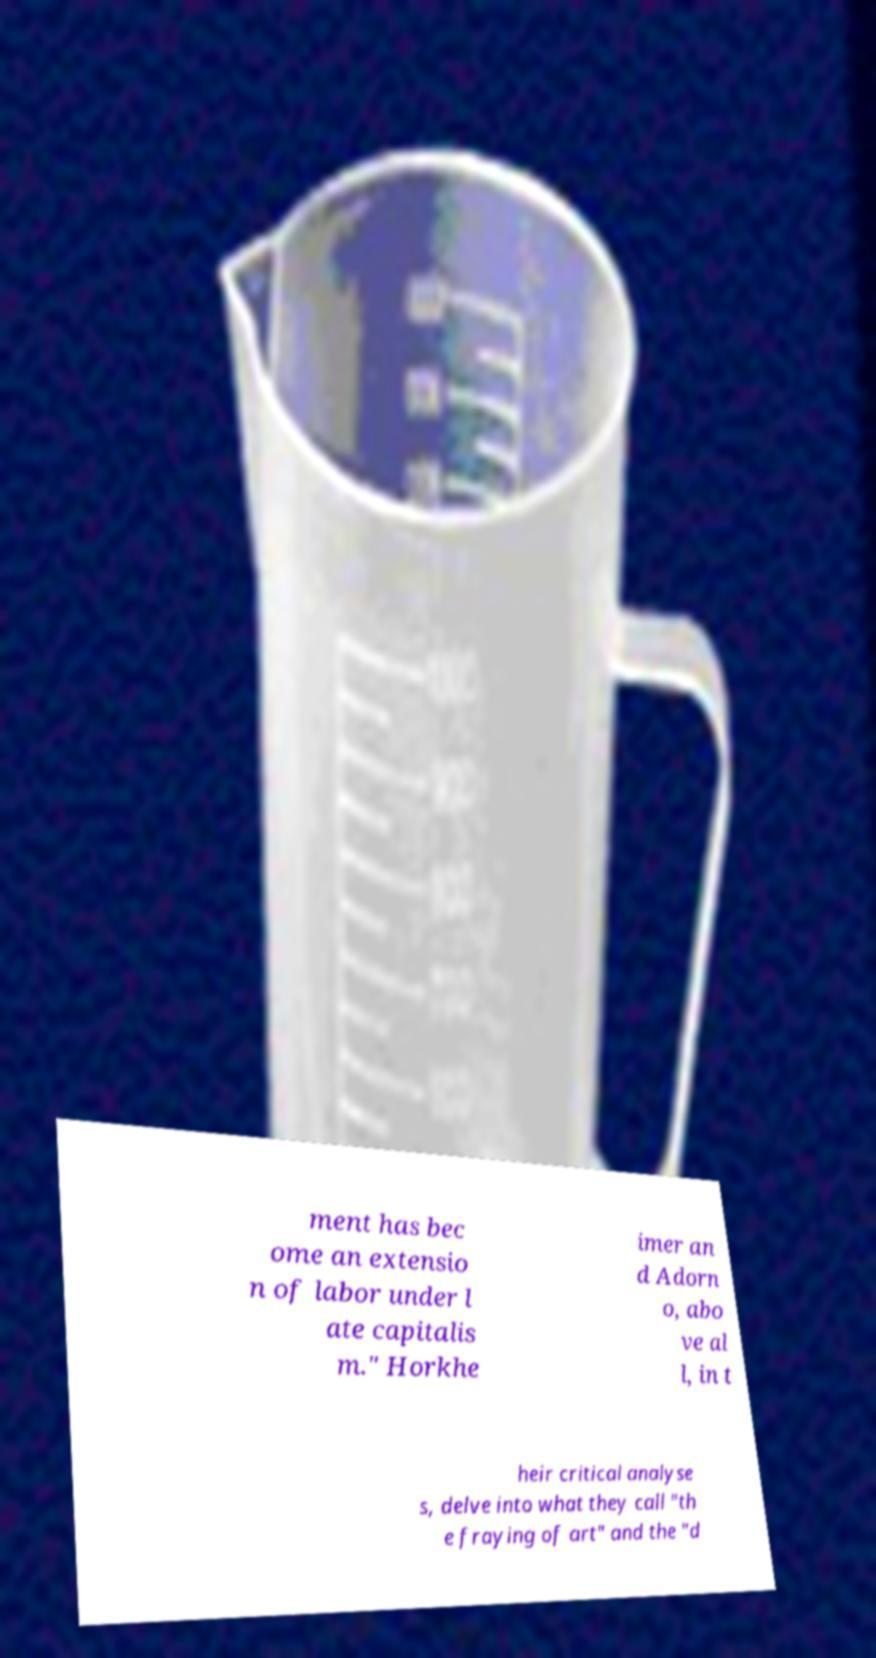Could you extract and type out the text from this image? ment has bec ome an extensio n of labor under l ate capitalis m." Horkhe imer an d Adorn o, abo ve al l, in t heir critical analyse s, delve into what they call "th e fraying of art" and the "d 